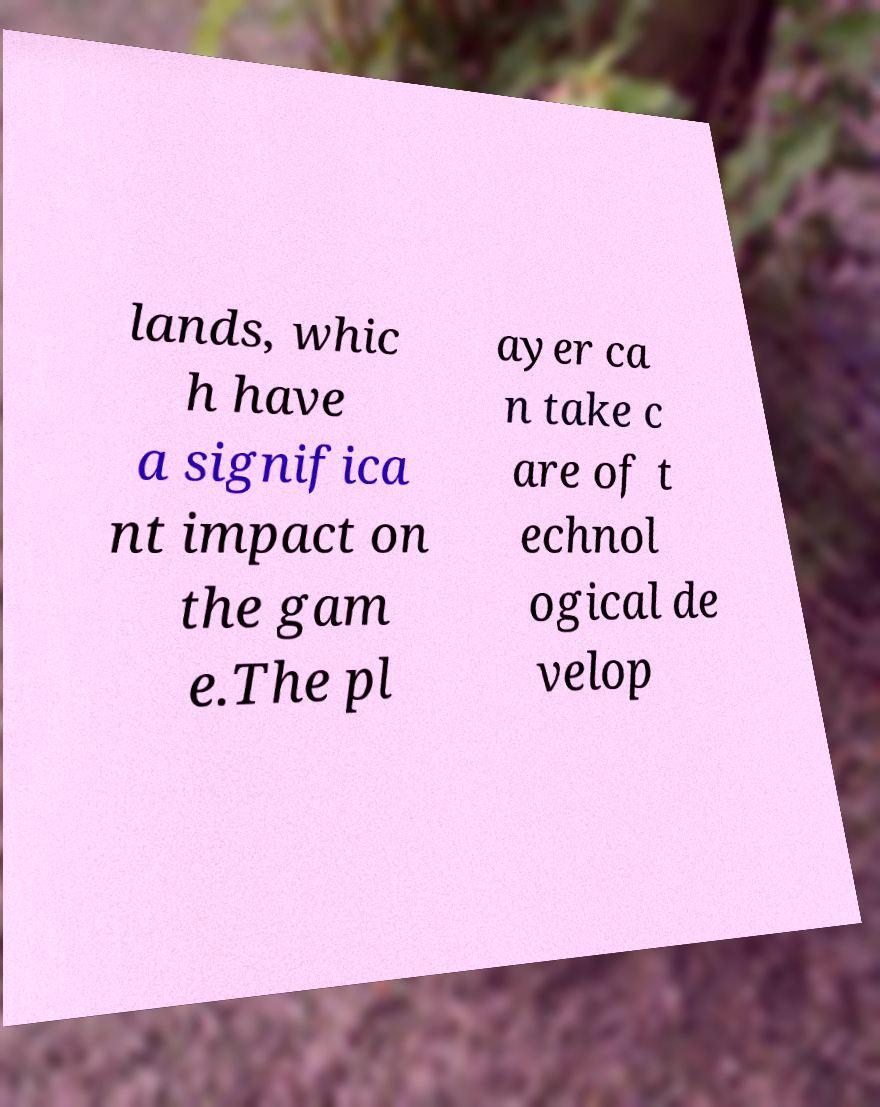Please identify and transcribe the text found in this image. lands, whic h have a significa nt impact on the gam e.The pl ayer ca n take c are of t echnol ogical de velop 